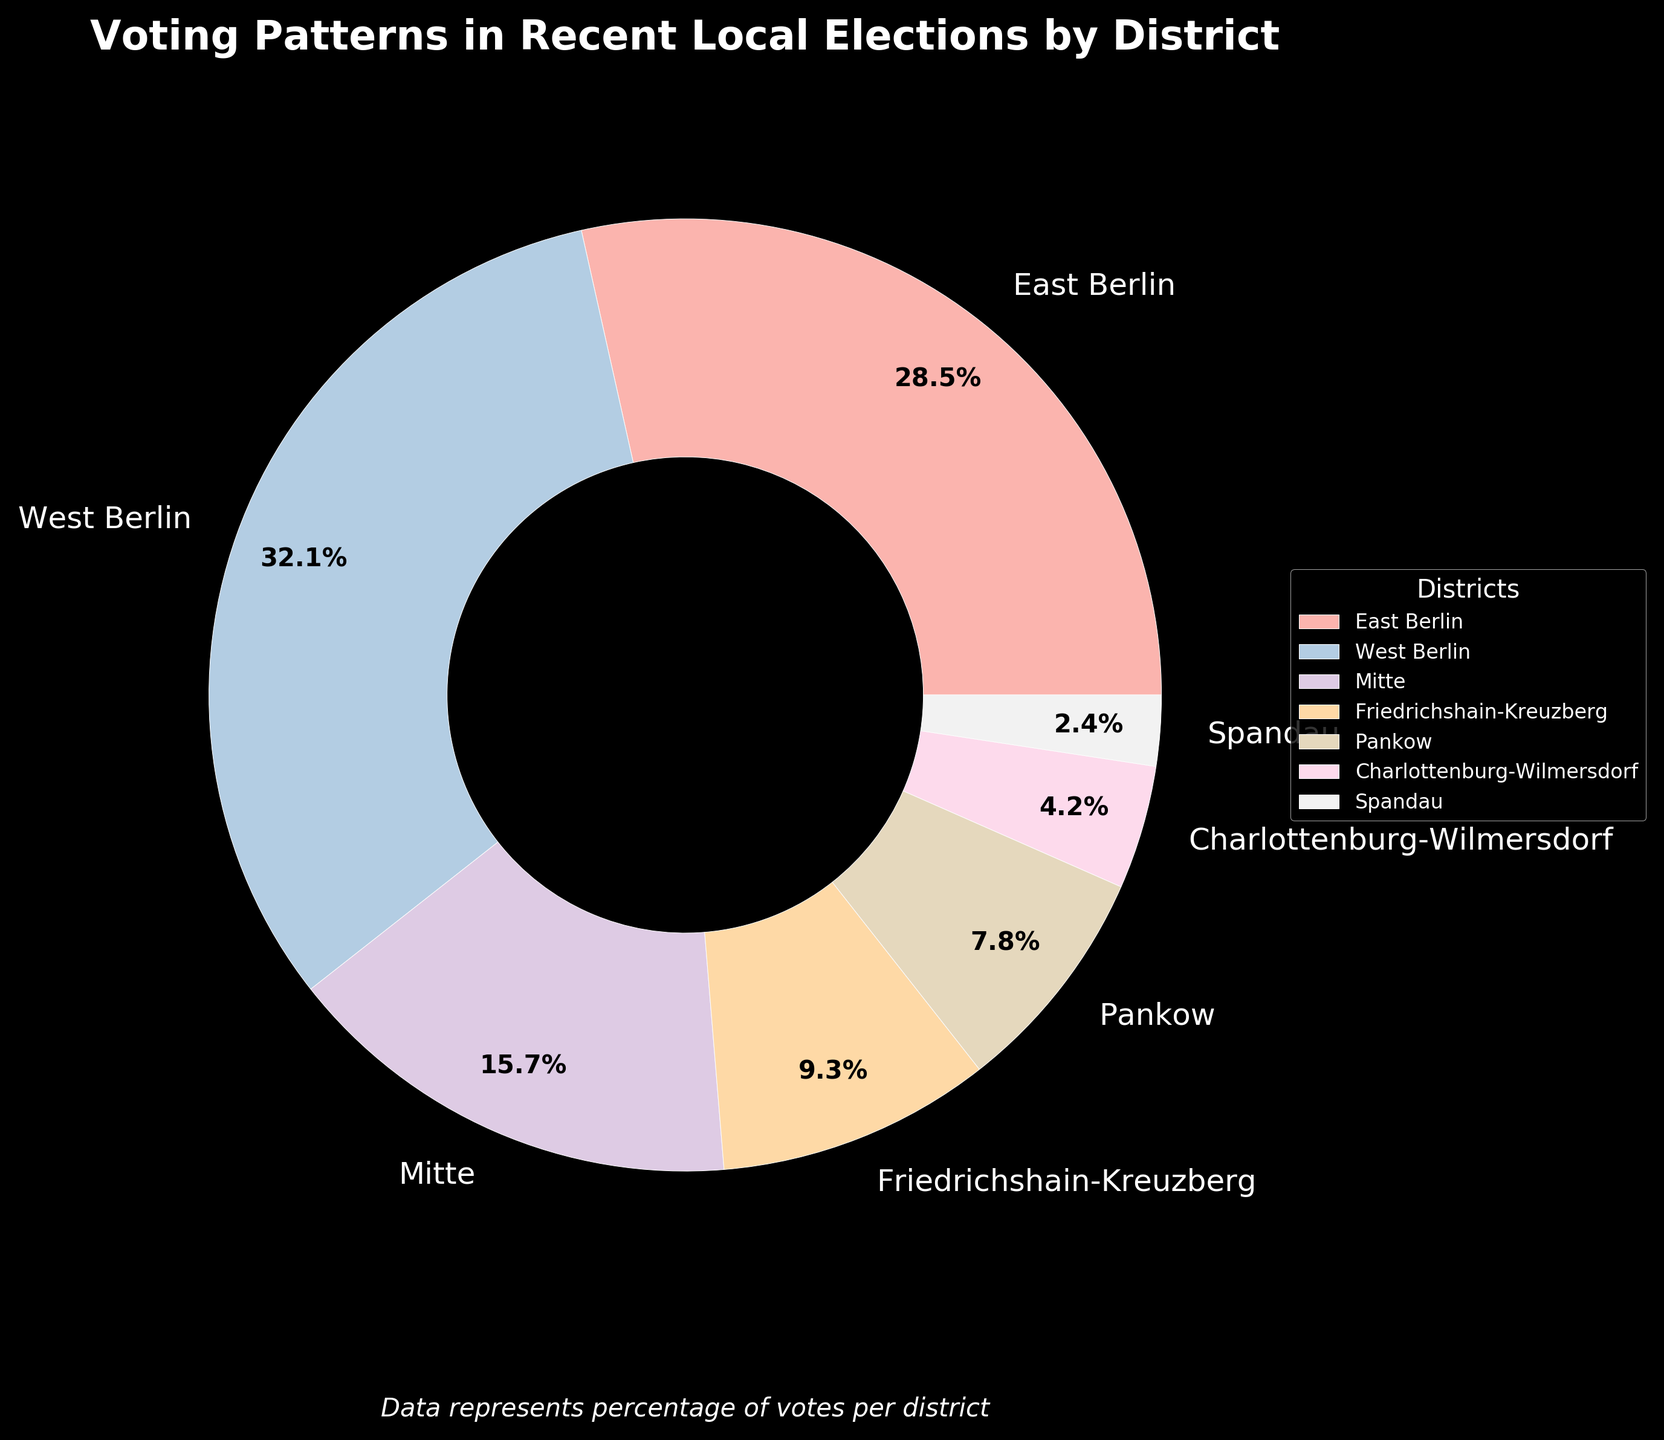Which district has the highest percentage of votes? The district with the highest percentage of votes can be identified by looking for the largest portion of the pie chart. West Berlin has the highest percentage at 32.1%.
Answer: West Berlin What is the combined percentage of votes for East Berlin and Mitte? To find the combined percentage, add the percentages of East Berlin and Mitte. East Berlin's percentage is 28.5% and Mitte's is 15.7%, so 28.5 + 15.7 = 44.2%.
Answer: 44.2% Which district has the smallest percentage of votes? The district with the smallest percentage of votes can be identified by looking for the smallest portion of the pie chart. Spandau has the smallest percentage at 2.4%.
Answer: Spandau How does the percentage of votes for Friedrichshain-Kreuzberg compare to Pankow? Compare the two values directly. Friedrichshain-Kreuzberg has 9.3%, and Pankow has 7.8%. Friedrichshain-Kreuzberg has a higher percentage.
Answer: Friedrichshain-Kreuzberg has a higher percentage What is the average percentage of votes across all districts? To find the average, sum all the percentages and divide by the number of districts. Sum: 28.5 + 32.1 + 15.7 + 9.3 + 7.8 + 4.2 + 2.4 = 100%. There are 7 districts, so 100 / 7 ≈ 14.3%.
Answer: 14.3% Which two districts together make up more than 50% of the votes? Identify the two largest segments and sum their percentages. West Berlin (32.1%) and East Berlin (28.5%) together make up 32.1 + 28.5 = 60.6%, which is more than 50%.
Answer: West Berlin and East Berlin By what percentage is West Berlin greater than East Berlin in terms of votes? Subtract East Berlin's percentage from West Berlin's percentage to find the difference. West Berlin is 32.1% and East Berlin is 28.5%, so the difference is 32.1 - 28.5 = 3.6%.
Answer: 3.6% What is the percentage difference between the two districts with the smallest and largest percentages? Identify the smallest and largest percentages: Spandau (2.4%) and West Berlin (32.1%). Subtract the smallest percentage from the largest: 32.1 - 2.4 = 29.7%.
Answer: 29.7% Which district's slice is represented in the darkest color in the pie chart? The darkest color in the pie chart represents East Berlin. The color scheme goes from light to dark, and East Berlin's slice is the darkest.
Answer: East Berlin Which districts have a vote percentage within 5% of each other? Look for pairs of districts where the difference in their percentages is 5% or less. Charlottenburg-Wilmersdorf (4.2%) and Pankow (7.8%) have a difference of 7.8% - 4.2% = 3.6%. Another pair is Friedrichshain-Kreuzberg (9.3%) and Mitte (15.7%), with a difference of 15.7% - 9.3% = 6.4% (which is slightly more than 5%).
Answer: Charlottenburg-Wilmersdorf and Pankow 